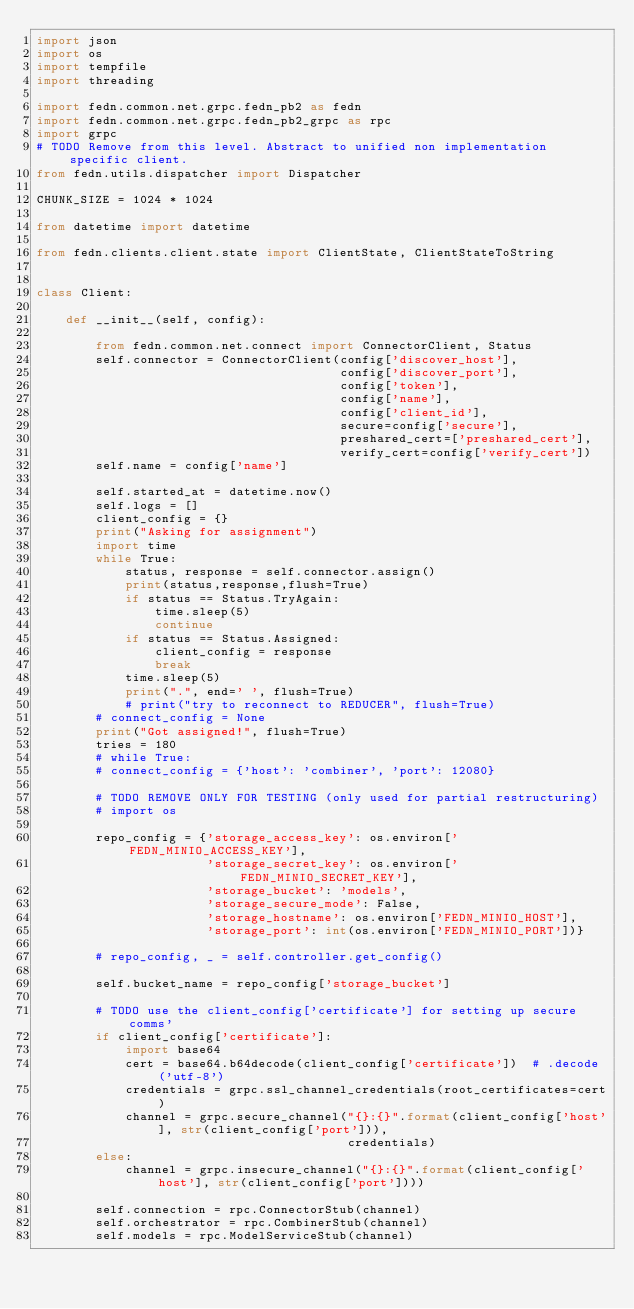<code> <loc_0><loc_0><loc_500><loc_500><_Python_>import json
import os
import tempfile
import threading

import fedn.common.net.grpc.fedn_pb2 as fedn
import fedn.common.net.grpc.fedn_pb2_grpc as rpc
import grpc
# TODO Remove from this level. Abstract to unified non implementation specific client.
from fedn.utils.dispatcher import Dispatcher

CHUNK_SIZE = 1024 * 1024

from datetime import datetime

from fedn.clients.client.state import ClientState, ClientStateToString


class Client:

    def __init__(self, config):

        from fedn.common.net.connect import ConnectorClient, Status
        self.connector = ConnectorClient(config['discover_host'],
                                         config['discover_port'],
                                         config['token'],
                                         config['name'],
                                         config['client_id'],
                                         secure=config['secure'],
                                         preshared_cert=['preshared_cert'],
                                         verify_cert=config['verify_cert'])
        self.name = config['name']

        self.started_at = datetime.now()
        self.logs = []
        client_config = {}
        print("Asking for assignment")
        import time
        while True:
            status, response = self.connector.assign()
            print(status,response,flush=True)
            if status == Status.TryAgain:
                time.sleep(5)
                continue
            if status == Status.Assigned:
                client_config = response
                break
            time.sleep(5)
            print(".", end=' ', flush=True)
            # print("try to reconnect to REDUCER", flush=True)
        # connect_config = None
        print("Got assigned!", flush=True)
        tries = 180
        # while True:
        # connect_config = {'host': 'combiner', 'port': 12080}

        # TODO REMOVE ONLY FOR TESTING (only used for partial restructuring)
        # import os

        repo_config = {'storage_access_key': os.environ['FEDN_MINIO_ACCESS_KEY'],
                       'storage_secret_key': os.environ['FEDN_MINIO_SECRET_KEY'],
                       'storage_bucket': 'models',
                       'storage_secure_mode': False,
                       'storage_hostname': os.environ['FEDN_MINIO_HOST'],
                       'storage_port': int(os.environ['FEDN_MINIO_PORT'])}

        # repo_config, _ = self.controller.get_config()

        self.bucket_name = repo_config['storage_bucket']

        # TODO use the client_config['certificate'] for setting up secure comms'
        if client_config['certificate']:
            import base64
            cert = base64.b64decode(client_config['certificate'])  # .decode('utf-8')
            credentials = grpc.ssl_channel_credentials(root_certificates=cert)
            channel = grpc.secure_channel("{}:{}".format(client_config['host'], str(client_config['port'])),
                                          credentials)
        else:
            channel = grpc.insecure_channel("{}:{}".format(client_config['host'], str(client_config['port'])))

        self.connection = rpc.ConnectorStub(channel)
        self.orchestrator = rpc.CombinerStub(channel)
        self.models = rpc.ModelServiceStub(channel)
</code> 